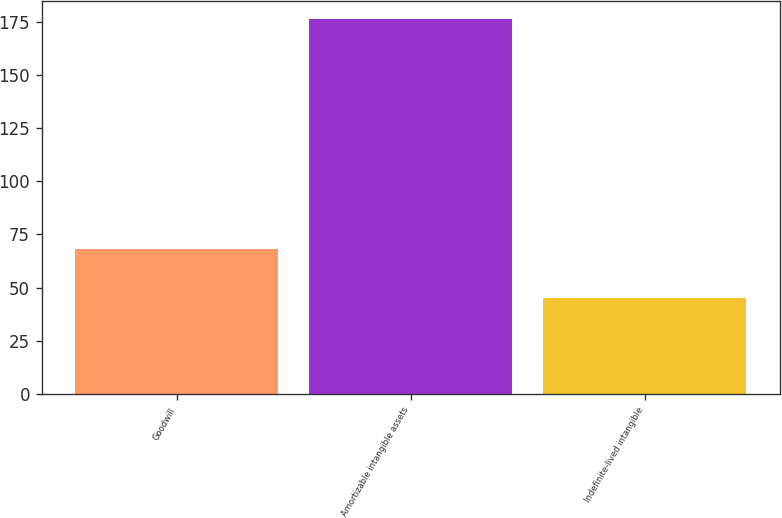<chart> <loc_0><loc_0><loc_500><loc_500><bar_chart><fcel>Goodwill<fcel>Amortizable intangible assets<fcel>Indefinite-lived intangible<nl><fcel>68<fcel>176<fcel>45<nl></chart> 